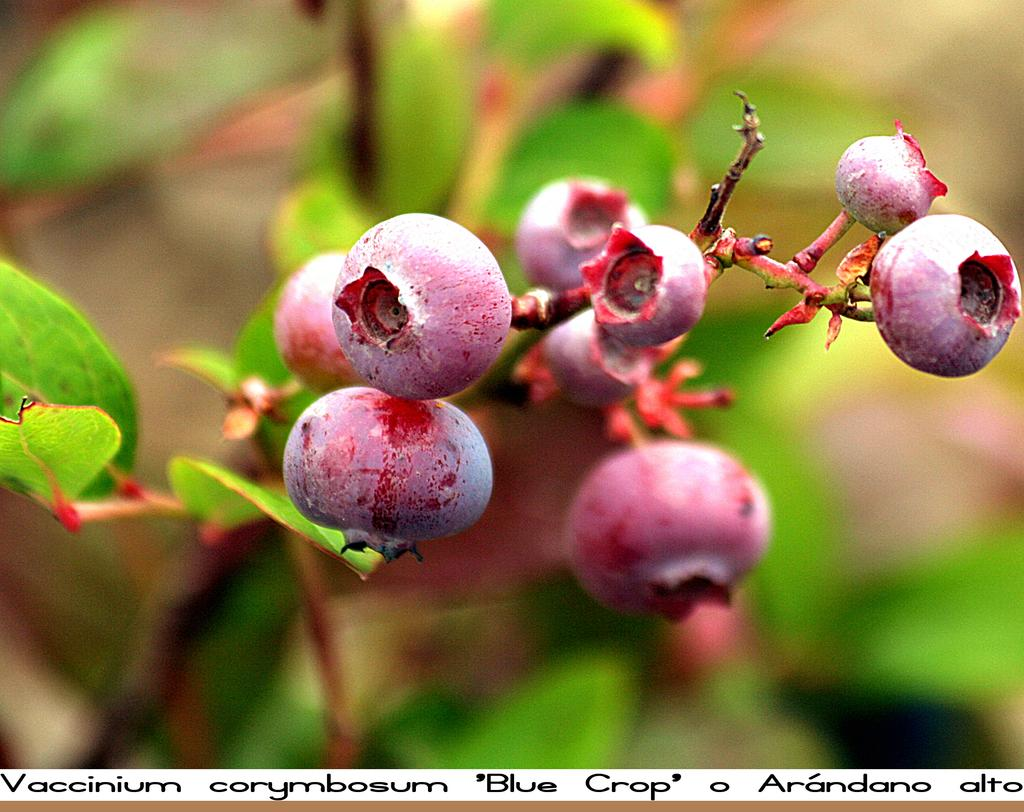What type of living organisms can be seen in the image? Plants can be seen in the image. What type of food items are present in the image? There are fruits in the image. What is the account balance of the person in the image? There is no person present in the image, and therefore no account balance can be determined. What type of channel is visible in the image? There is no channel present in the image. 